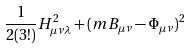<formula> <loc_0><loc_0><loc_500><loc_500>\frac { 1 } { 2 ( 3 ! ) } H _ { \mu \nu \lambda } ^ { 2 } + ( m B _ { \mu \nu } - \Phi _ { \mu \nu } ) ^ { 2 }</formula> 